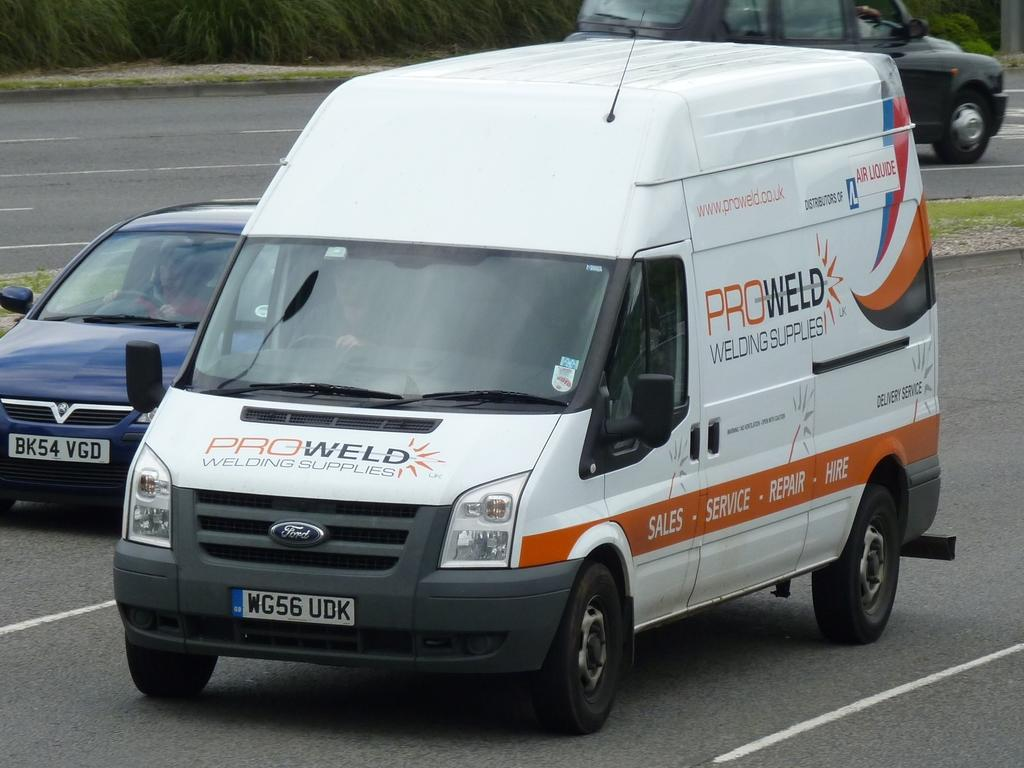Provide a one-sentence caption for the provided image. The company van is from the company Proweld. 